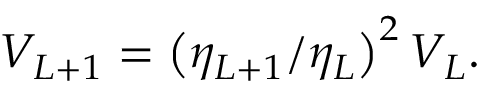Convert formula to latex. <formula><loc_0><loc_0><loc_500><loc_500>V _ { L + 1 } = \left ( \eta _ { L + 1 } / \eta _ { L } \right ) ^ { 2 } V _ { L } .</formula> 